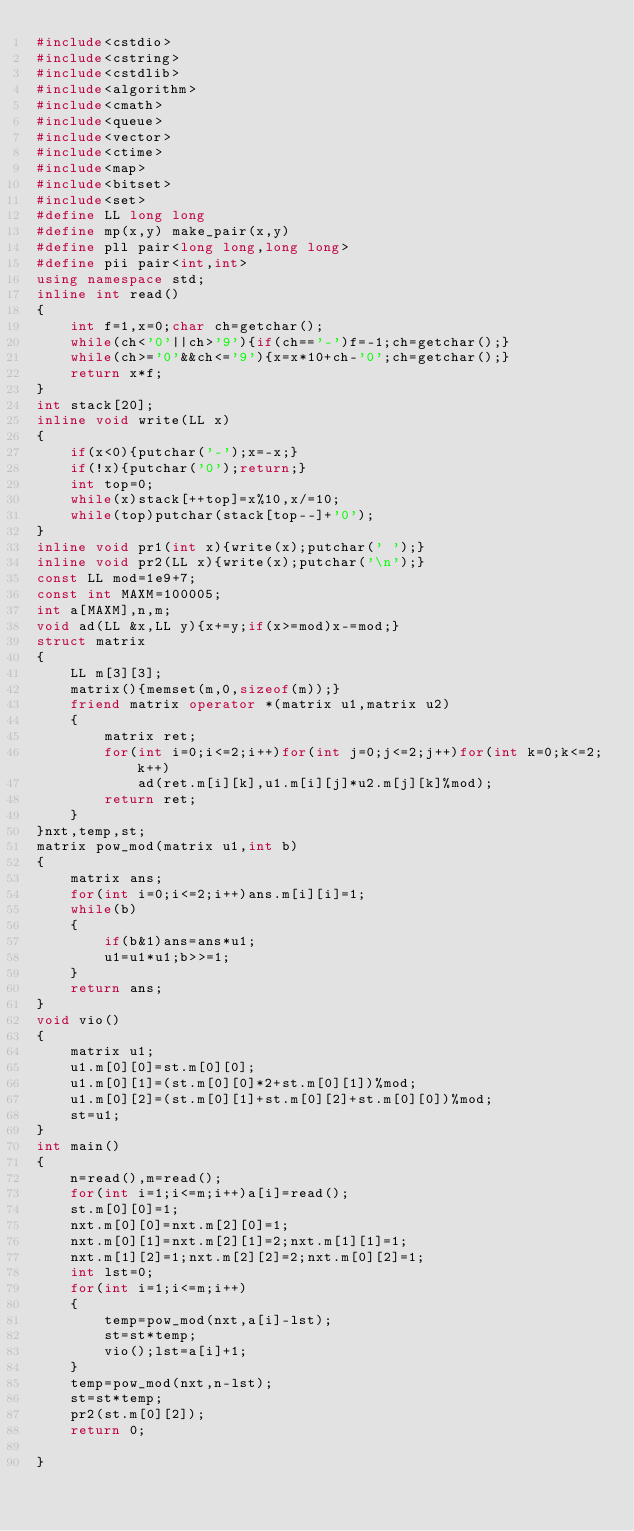Convert code to text. <code><loc_0><loc_0><loc_500><loc_500><_C++_>#include<cstdio>
#include<cstring>
#include<cstdlib>
#include<algorithm>
#include<cmath>
#include<queue>
#include<vector>
#include<ctime>
#include<map>
#include<bitset>
#include<set>
#define LL long long
#define mp(x,y) make_pair(x,y)
#define pll pair<long long,long long>
#define pii pair<int,int>
using namespace std;
inline int read()
{
	int f=1,x=0;char ch=getchar();
	while(ch<'0'||ch>'9'){if(ch=='-')f=-1;ch=getchar();}
	while(ch>='0'&&ch<='9'){x=x*10+ch-'0';ch=getchar();}
	return x*f;
}
int stack[20];
inline void write(LL x)
{
	if(x<0){putchar('-');x=-x;}
    if(!x){putchar('0');return;}
    int top=0;
    while(x)stack[++top]=x%10,x/=10;
    while(top)putchar(stack[top--]+'0');
}
inline void pr1(int x){write(x);putchar(' ');}
inline void pr2(LL x){write(x);putchar('\n');}
const LL mod=1e9+7;
const int MAXM=100005;
int a[MAXM],n,m;
void ad(LL &x,LL y){x+=y;if(x>=mod)x-=mod;}
struct matrix
{
	LL m[3][3];
	matrix(){memset(m,0,sizeof(m));}
	friend matrix operator *(matrix u1,matrix u2)
	{
		matrix ret;
		for(int i=0;i<=2;i++)for(int j=0;j<=2;j++)for(int k=0;k<=2;k++)
			ad(ret.m[i][k],u1.m[i][j]*u2.m[j][k]%mod);
		return ret;
	}
}nxt,temp,st;
matrix pow_mod(matrix u1,int b)
{
	matrix ans;
	for(int i=0;i<=2;i++)ans.m[i][i]=1;
	while(b)
	{
		if(b&1)ans=ans*u1;
		u1=u1*u1;b>>=1;
	}
	return ans;
}
void vio()
{
	matrix u1;
	u1.m[0][0]=st.m[0][0];
	u1.m[0][1]=(st.m[0][0]*2+st.m[0][1])%mod;
	u1.m[0][2]=(st.m[0][1]+st.m[0][2]+st.m[0][0])%mod;
	st=u1;
}
int main()
{
	n=read(),m=read();
	for(int i=1;i<=m;i++)a[i]=read();
	st.m[0][0]=1;
	nxt.m[0][0]=nxt.m[2][0]=1;
	nxt.m[0][1]=nxt.m[2][1]=2;nxt.m[1][1]=1;
	nxt.m[1][2]=1;nxt.m[2][2]=2;nxt.m[0][2]=1;
	int lst=0;
	for(int i=1;i<=m;i++)
	{
		temp=pow_mod(nxt,a[i]-lst);
		st=st*temp;
		vio();lst=a[i]+1;
	}
	temp=pow_mod(nxt,n-lst);
	st=st*temp;
	pr2(st.m[0][2]);
	return 0;
	
}
</code> 